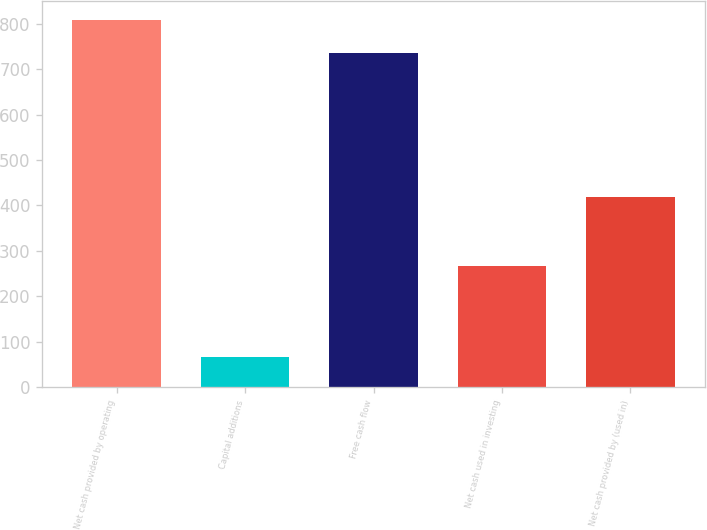Convert chart to OTSL. <chart><loc_0><loc_0><loc_500><loc_500><bar_chart><fcel>Net cash provided by operating<fcel>Capital additions<fcel>Free cash flow<fcel>Net cash used in investing<fcel>Net cash provided by (used in)<nl><fcel>809.16<fcel>67.7<fcel>735.6<fcel>267.6<fcel>417.7<nl></chart> 